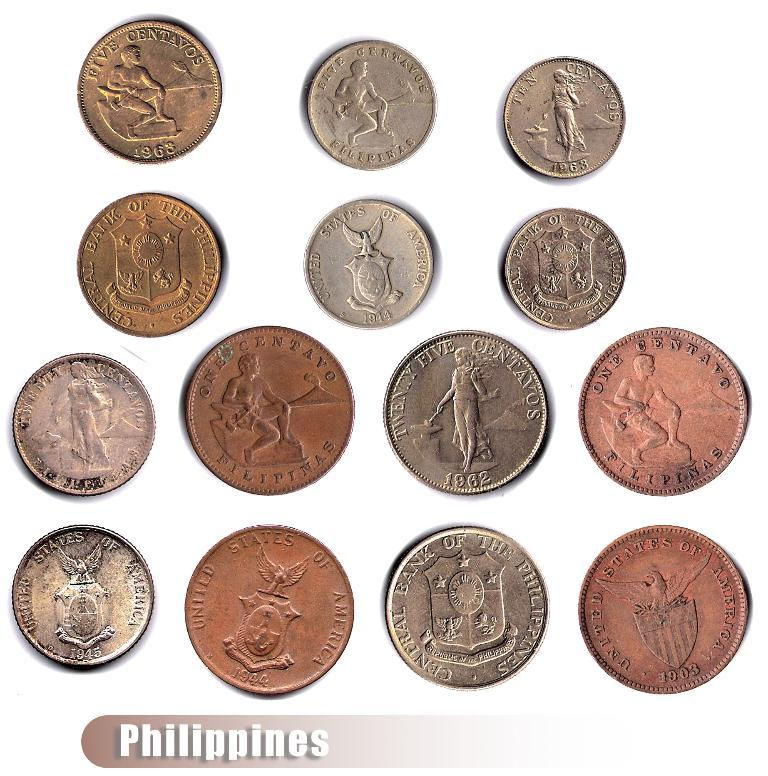<image>
Present a compact description of the photo's key features. An array of different colored monetary coins from the Philippines. 